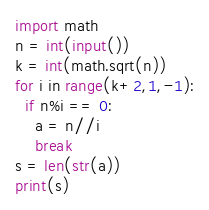<code> <loc_0><loc_0><loc_500><loc_500><_Python_>import math
n = int(input())
k = int(math.sqrt(n))
for i in range(k+2,1,-1):
  if n%i == 0:
    a = n//i
    break
s = len(str(a))
print(s)</code> 